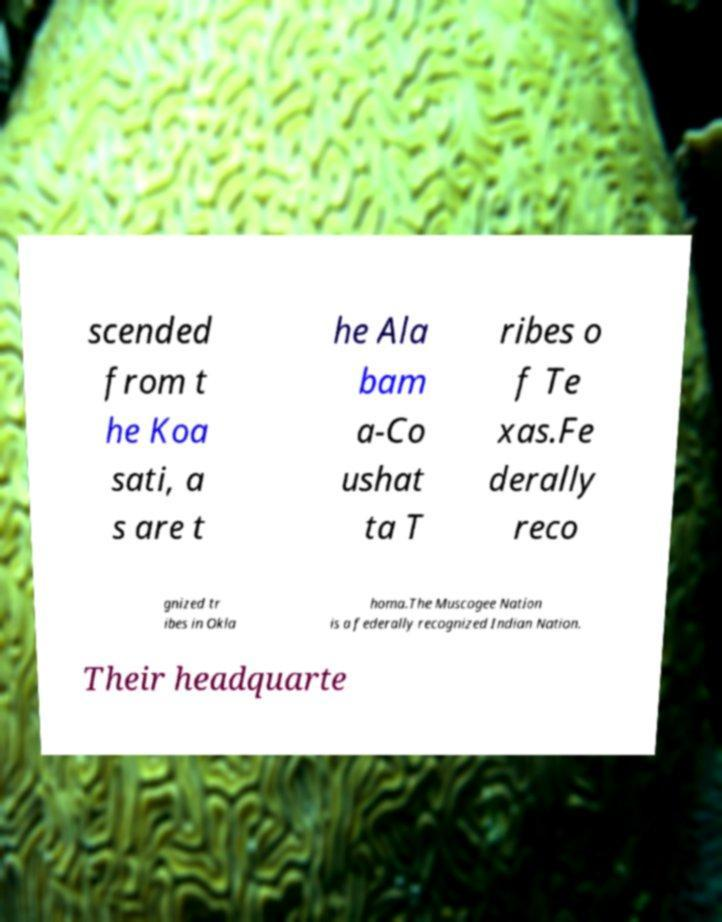Could you extract and type out the text from this image? scended from t he Koa sati, a s are t he Ala bam a-Co ushat ta T ribes o f Te xas.Fe derally reco gnized tr ibes in Okla homa.The Muscogee Nation is a federally recognized Indian Nation. Their headquarte 